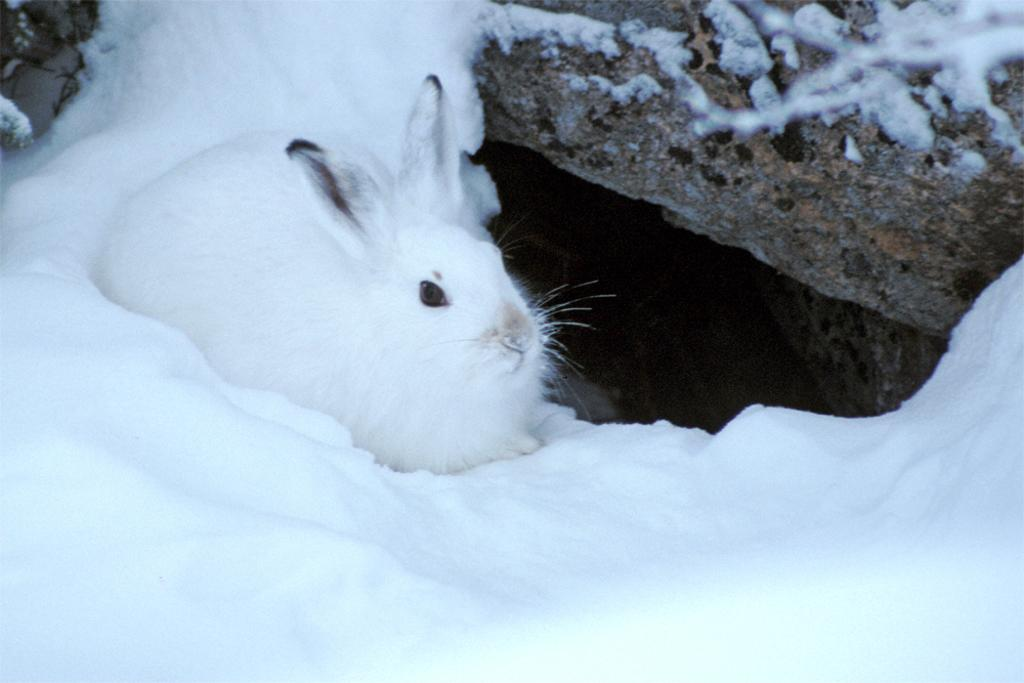What animal can be seen in the image? There is a rabbit in the image. What is the rabbit standing on? The rabbit is on the snow. What object is located beside the rabbit? There is a stone beside the rabbit. What color is the rabbit? The rabbit is white in color. What type of joke is the rabbit telling in the image? There is no indication in the image that the rabbit is telling a joke, as rabbits do not have the ability to speak or tell jokes. 